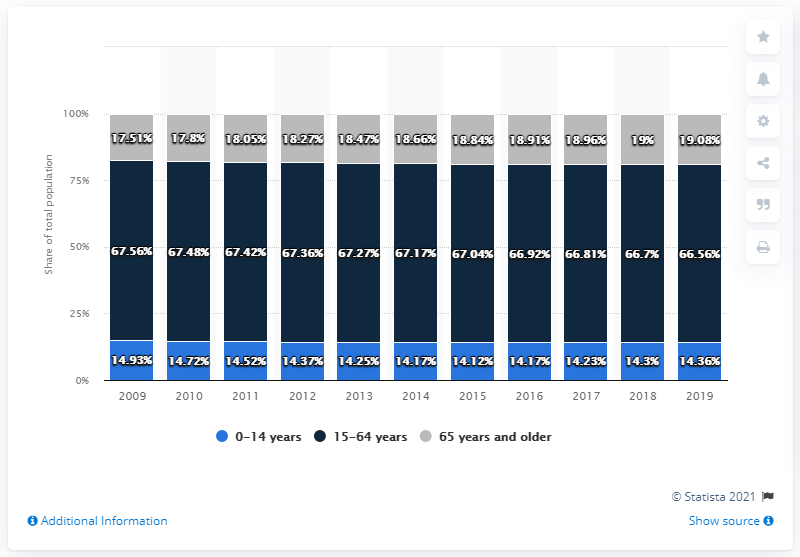Outline some significant characteristics in this image. The difference between the 2018 and 2019 rates in the 65 years and older category is 0.08. In 2015, the category that recorded the highest proportion of youth (0-14 years) was 0-14 years. 